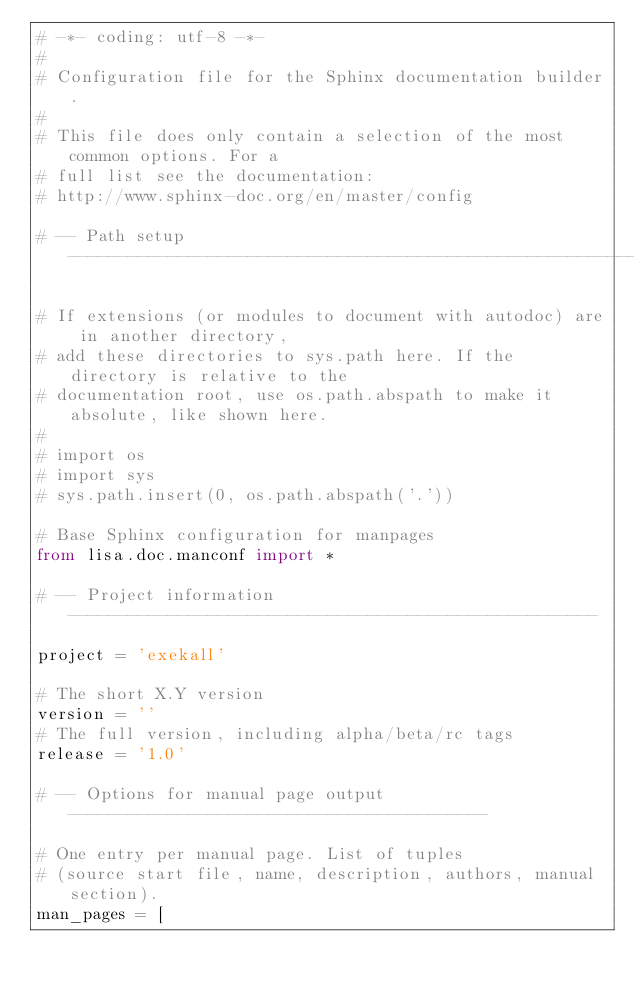Convert code to text. <code><loc_0><loc_0><loc_500><loc_500><_Python_># -*- coding: utf-8 -*-
#
# Configuration file for the Sphinx documentation builder.
#
# This file does only contain a selection of the most common options. For a
# full list see the documentation:
# http://www.sphinx-doc.org/en/master/config

# -- Path setup --------------------------------------------------------------

# If extensions (or modules to document with autodoc) are in another directory,
# add these directories to sys.path here. If the directory is relative to the
# documentation root, use os.path.abspath to make it absolute, like shown here.
#
# import os
# import sys
# sys.path.insert(0, os.path.abspath('.'))

# Base Sphinx configuration for manpages
from lisa.doc.manconf import *

# -- Project information -----------------------------------------------------

project = 'exekall'

# The short X.Y version
version = ''
# The full version, including alpha/beta/rc tags
release = '1.0'

# -- Options for manual page output ------------------------------------------

# One entry per manual page. List of tuples
# (source start file, name, description, authors, manual section).
man_pages = [</code> 